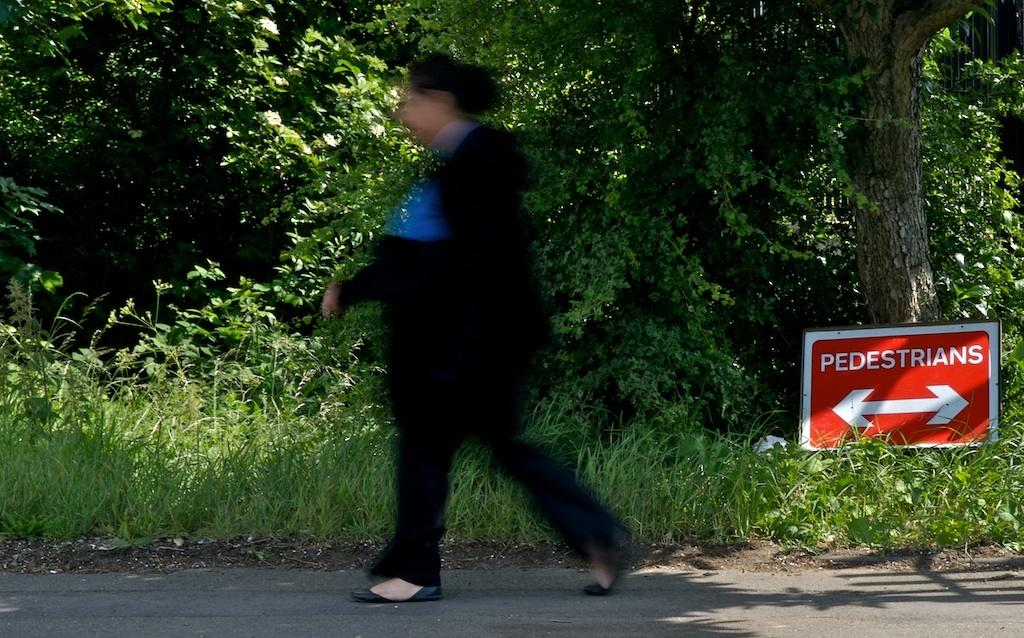What is the main subject of the image? There is a person walking in the image. Where is the person located? The person is on the road. What can be seen in the background of the image? There are trees and a board visible in the background. Can you see the moon in the image? No, the moon is not present in the image. What type of stocking is the person wearing in the image? There is no information about the person's clothing, including stockings, in the image. 